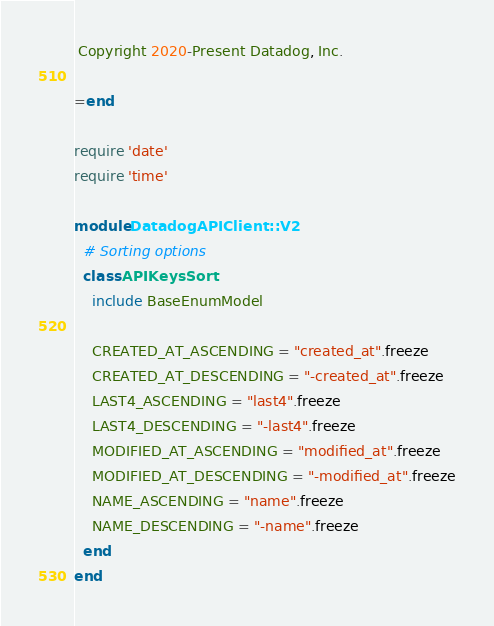Convert code to text. <code><loc_0><loc_0><loc_500><loc_500><_Ruby_> Copyright 2020-Present Datadog, Inc.

=end

require 'date'
require 'time'

module DatadogAPIClient::V2
  # Sorting options
  class APIKeysSort
    include BaseEnumModel

    CREATED_AT_ASCENDING = "created_at".freeze
    CREATED_AT_DESCENDING = "-created_at".freeze
    LAST4_ASCENDING = "last4".freeze
    LAST4_DESCENDING = "-last4".freeze
    MODIFIED_AT_ASCENDING = "modified_at".freeze
    MODIFIED_AT_DESCENDING = "-modified_at".freeze
    NAME_ASCENDING = "name".freeze
    NAME_DESCENDING = "-name".freeze
  end
end
</code> 